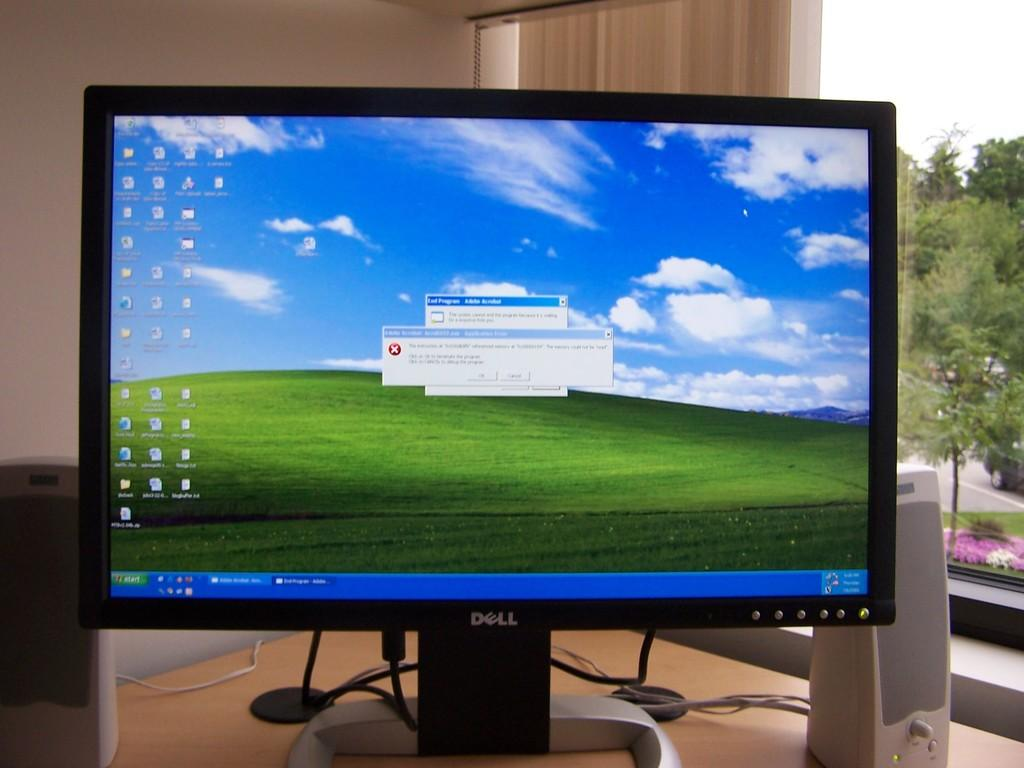<image>
Share a concise interpretation of the image provided. A Dell monitor displays a Microsoft Windows page. 